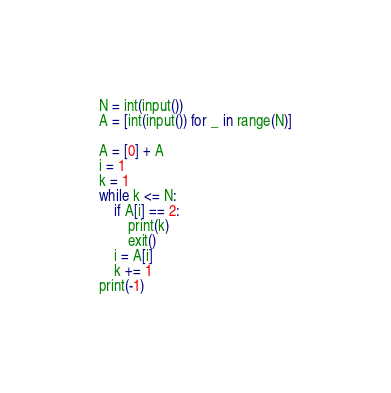<code> <loc_0><loc_0><loc_500><loc_500><_Python_>N = int(input())
A = [int(input()) for _ in range(N)]

A = [0] + A
i = 1
k = 1
while k <= N:
    if A[i] == 2:
        print(k)
        exit()
    i = A[i]
    k += 1
print(-1)
</code> 